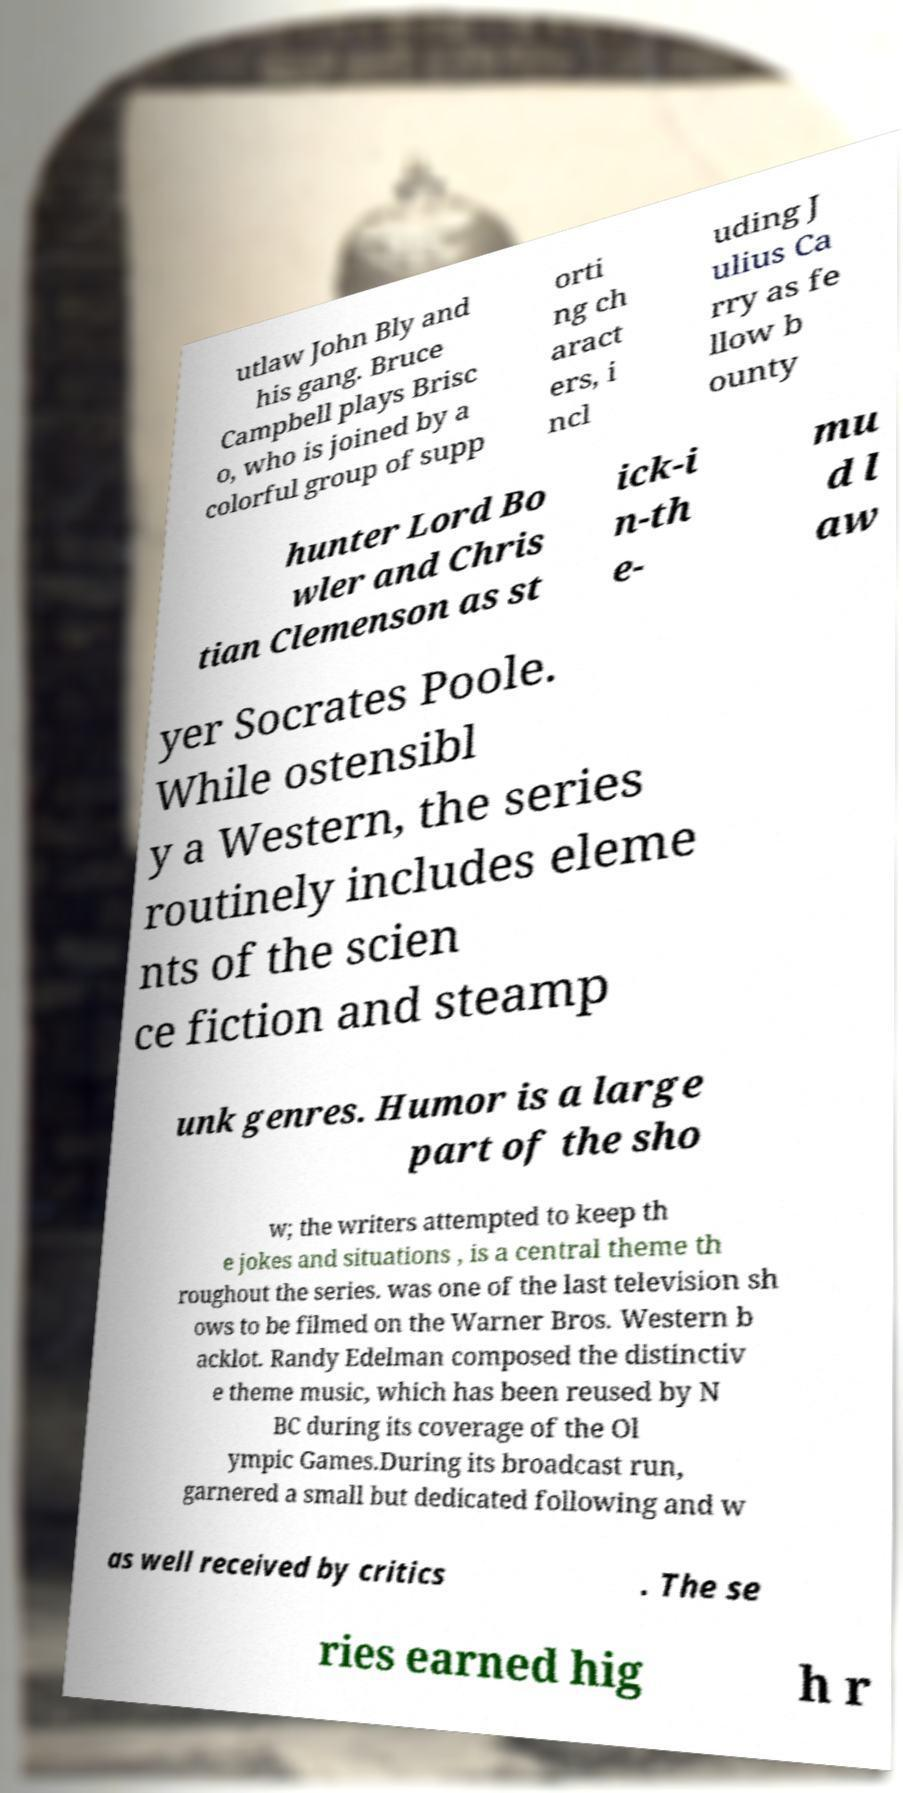There's text embedded in this image that I need extracted. Can you transcribe it verbatim? utlaw John Bly and his gang. Bruce Campbell plays Brisc o, who is joined by a colorful group of supp orti ng ch aract ers, i ncl uding J ulius Ca rry as fe llow b ounty hunter Lord Bo wler and Chris tian Clemenson as st ick-i n-th e- mu d l aw yer Socrates Poole. While ostensibl y a Western, the series routinely includes eleme nts of the scien ce fiction and steamp unk genres. Humor is a large part of the sho w; the writers attempted to keep th e jokes and situations , is a central theme th roughout the series. was one of the last television sh ows to be filmed on the Warner Bros. Western b acklot. Randy Edelman composed the distinctiv e theme music, which has been reused by N BC during its coverage of the Ol ympic Games.During its broadcast run, garnered a small but dedicated following and w as well received by critics . The se ries earned hig h r 